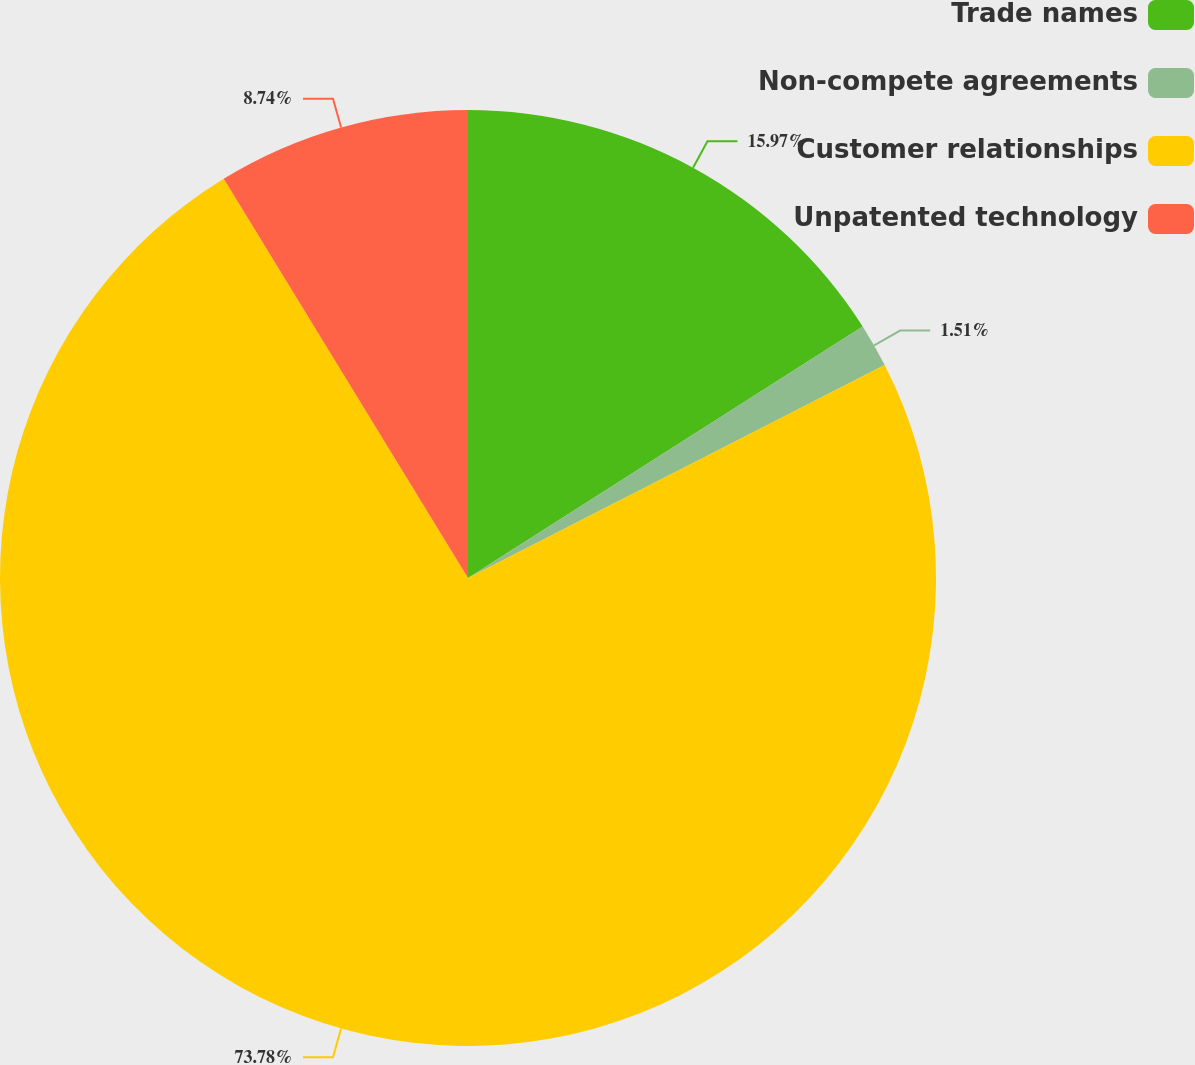<chart> <loc_0><loc_0><loc_500><loc_500><pie_chart><fcel>Trade names<fcel>Non-compete agreements<fcel>Customer relationships<fcel>Unpatented technology<nl><fcel>15.97%<fcel>1.51%<fcel>73.79%<fcel>8.74%<nl></chart> 